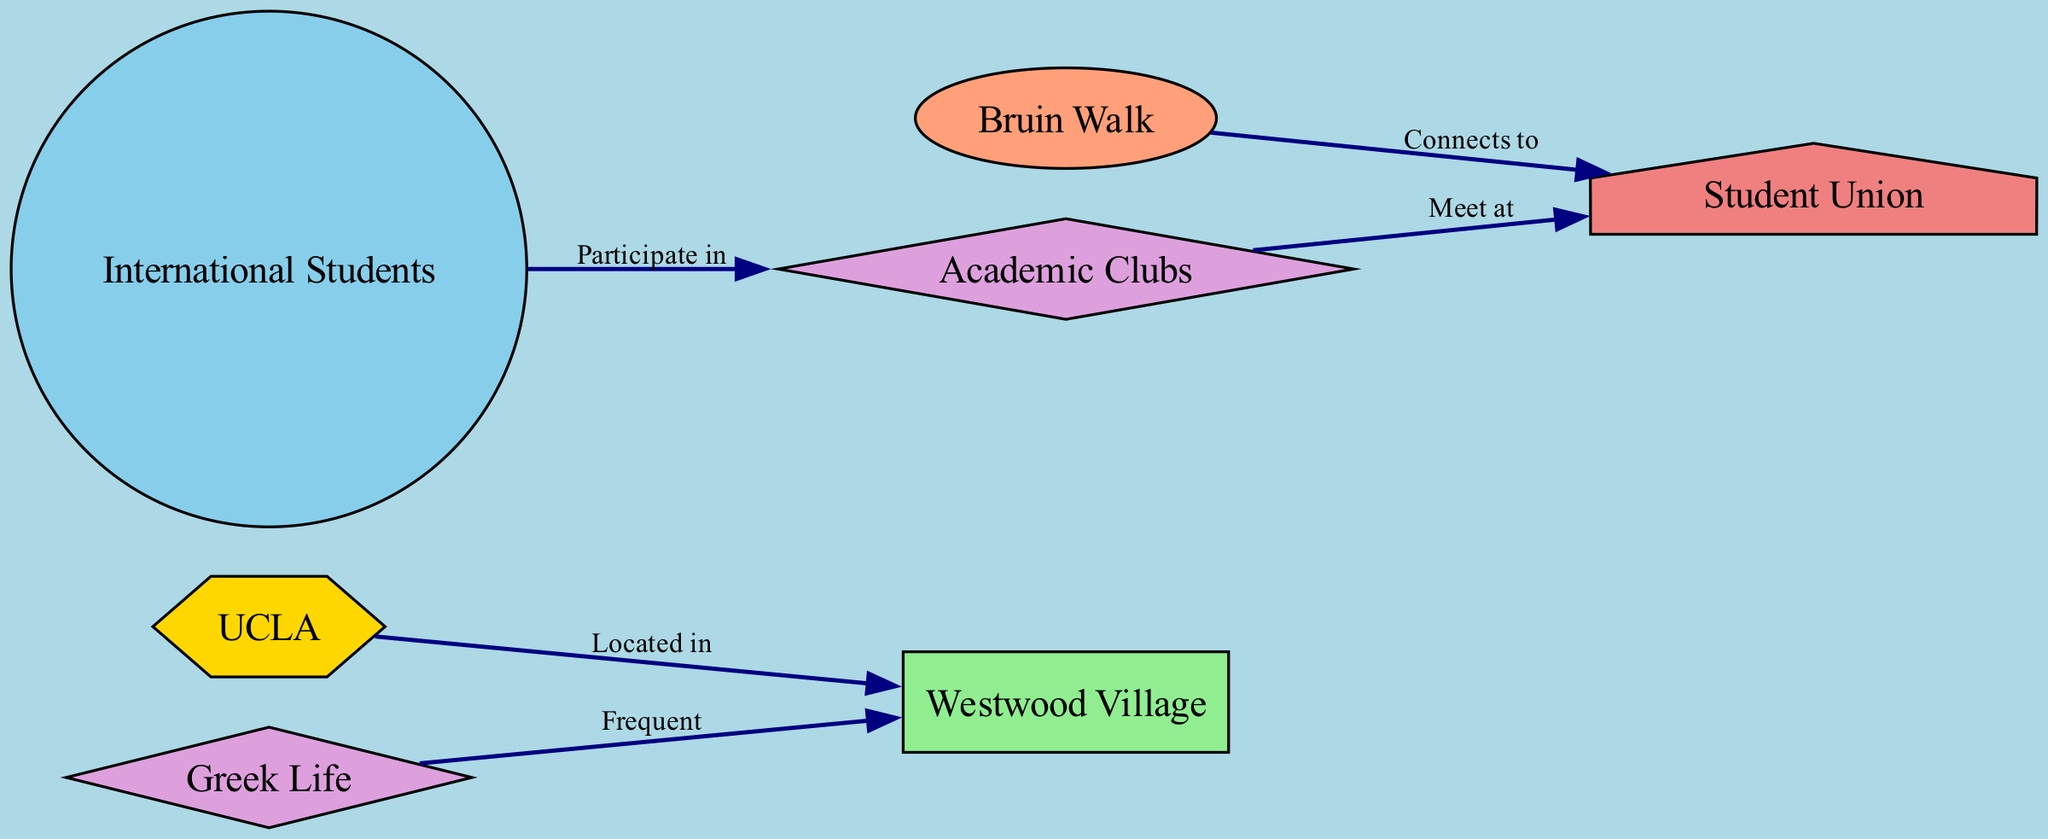What type of institution is represented in the diagram? The diagram includes a node labeled "UCLA," which is categorized as an "Institution."
Answer: Institution How many student organizations are present in the diagram? Upon reviewing the nodes, there are two nodes labeled "Greek Life" and "Academic Clubs," which are categorized as student organizations. Thus, there are two student organizations present.
Answer: 2 What location is UCLA associated with? The edge labeled "Located in" connects "UCLA" to "Westwood Village," indicating that UCLA is associated with Westwood Village.
Answer: Westwood Village Which group participates in Academic Clubs? The edge labeled "Participate in" connects the node "International Students" to "Academic Clubs," indicating that International Students participate in Academic Clubs.
Answer: International Students Where do Academic Clubs meet? The edge labeled "Meet at" connects "Academic Clubs" to "Student Union," indicating that Academic Clubs meet at the Student Union.
Answer: Student Union Which campus area is connected to the Student Union? The edge labeled "Connects to" connects "Bruin Walk" to "Student Union," indicating that Bruin Walk is the campus area connected to the Student Union.
Answer: Bruin Walk What type of building is the Student Union categorized as? The diagram lists the node "Student Union" and classifies it under "Campus Building."
Answer: Campus Building How does Greek Life interact with Westwood Village? The edge labeled "Frequent" connects "Greek Life" to "Westwood Village," indicating that Greek Life frequents Westwood Village.
Answer: Frequent Which group is involved with both Academic Clubs and International Students? Although the "International Students" group participates in "Academic Clubs," there isn't a direct association of a single group involved with both; rather, International Students are the group that interacts with Academic Clubs.
Answer: International Students 